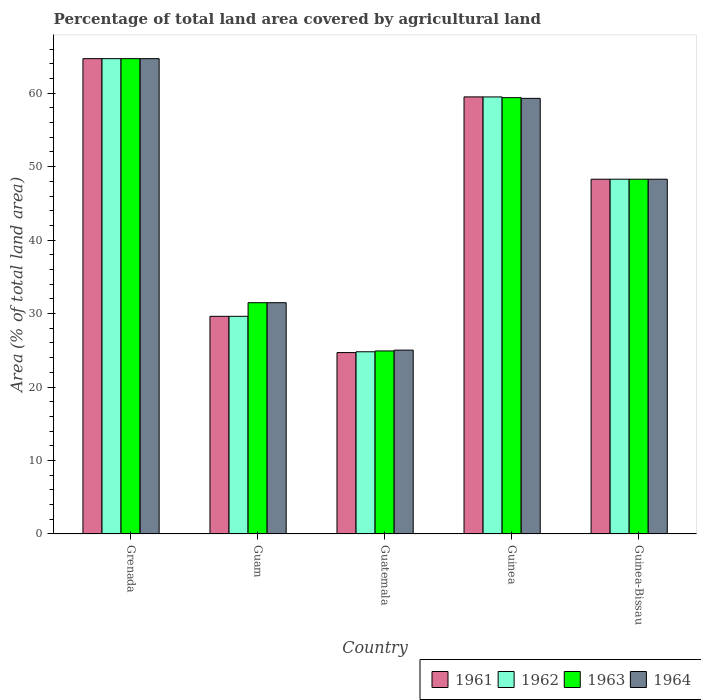How many groups of bars are there?
Your response must be concise. 5. Are the number of bars per tick equal to the number of legend labels?
Offer a terse response. Yes. How many bars are there on the 1st tick from the left?
Make the answer very short. 4. How many bars are there on the 1st tick from the right?
Make the answer very short. 4. What is the label of the 2nd group of bars from the left?
Offer a terse response. Guam. What is the percentage of agricultural land in 1961 in Guatemala?
Offer a terse response. 24.69. Across all countries, what is the maximum percentage of agricultural land in 1961?
Keep it short and to the point. 64.71. Across all countries, what is the minimum percentage of agricultural land in 1964?
Keep it short and to the point. 25.03. In which country was the percentage of agricultural land in 1963 maximum?
Give a very brief answer. Grenada. In which country was the percentage of agricultural land in 1963 minimum?
Give a very brief answer. Guatemala. What is the total percentage of agricultural land in 1963 in the graph?
Make the answer very short. 228.79. What is the difference between the percentage of agricultural land in 1964 in Guam and that in Guatemala?
Your answer should be compact. 6.45. What is the difference between the percentage of agricultural land in 1962 in Guam and the percentage of agricultural land in 1964 in Guatemala?
Ensure brevity in your answer.  4.6. What is the average percentage of agricultural land in 1963 per country?
Your answer should be very brief. 45.76. What is the difference between the percentage of agricultural land of/in 1962 and percentage of agricultural land of/in 1963 in Guatemala?
Offer a terse response. -0.11. What is the ratio of the percentage of agricultural land in 1961 in Guam to that in Guinea?
Offer a very short reply. 0.5. What is the difference between the highest and the second highest percentage of agricultural land in 1962?
Your response must be concise. 16.41. What is the difference between the highest and the lowest percentage of agricultural land in 1963?
Ensure brevity in your answer.  39.79. Is it the case that in every country, the sum of the percentage of agricultural land in 1961 and percentage of agricultural land in 1962 is greater than the sum of percentage of agricultural land in 1963 and percentage of agricultural land in 1964?
Your answer should be very brief. No. What does the 2nd bar from the left in Guam represents?
Make the answer very short. 1962. What does the 3rd bar from the right in Guinea represents?
Keep it short and to the point. 1962. Is it the case that in every country, the sum of the percentage of agricultural land in 1961 and percentage of agricultural land in 1962 is greater than the percentage of agricultural land in 1964?
Your answer should be very brief. Yes. Are all the bars in the graph horizontal?
Provide a short and direct response. No. Are the values on the major ticks of Y-axis written in scientific E-notation?
Make the answer very short. No. Does the graph contain any zero values?
Offer a terse response. No. Does the graph contain grids?
Give a very brief answer. No. How many legend labels are there?
Your answer should be compact. 4. What is the title of the graph?
Offer a very short reply. Percentage of total land area covered by agricultural land. Does "2002" appear as one of the legend labels in the graph?
Offer a very short reply. No. What is the label or title of the X-axis?
Offer a very short reply. Country. What is the label or title of the Y-axis?
Offer a terse response. Area (% of total land area). What is the Area (% of total land area) in 1961 in Grenada?
Provide a short and direct response. 64.71. What is the Area (% of total land area) in 1962 in Grenada?
Provide a succinct answer. 64.71. What is the Area (% of total land area) of 1963 in Grenada?
Your answer should be very brief. 64.71. What is the Area (% of total land area) of 1964 in Grenada?
Your response must be concise. 64.71. What is the Area (% of total land area) of 1961 in Guam?
Provide a short and direct response. 29.63. What is the Area (% of total land area) of 1962 in Guam?
Give a very brief answer. 29.63. What is the Area (% of total land area) of 1963 in Guam?
Keep it short and to the point. 31.48. What is the Area (% of total land area) of 1964 in Guam?
Offer a very short reply. 31.48. What is the Area (% of total land area) of 1961 in Guatemala?
Ensure brevity in your answer.  24.69. What is the Area (% of total land area) in 1962 in Guatemala?
Make the answer very short. 24.8. What is the Area (% of total land area) in 1963 in Guatemala?
Keep it short and to the point. 24.92. What is the Area (% of total land area) in 1964 in Guatemala?
Your answer should be compact. 25.03. What is the Area (% of total land area) in 1961 in Guinea?
Offer a very short reply. 59.5. What is the Area (% of total land area) in 1962 in Guinea?
Offer a very short reply. 59.49. What is the Area (% of total land area) of 1963 in Guinea?
Ensure brevity in your answer.  59.4. What is the Area (% of total land area) of 1964 in Guinea?
Your answer should be very brief. 59.3. What is the Area (% of total land area) of 1961 in Guinea-Bissau?
Give a very brief answer. 48.29. What is the Area (% of total land area) in 1962 in Guinea-Bissau?
Make the answer very short. 48.29. What is the Area (% of total land area) of 1963 in Guinea-Bissau?
Provide a succinct answer. 48.29. What is the Area (% of total land area) in 1964 in Guinea-Bissau?
Keep it short and to the point. 48.29. Across all countries, what is the maximum Area (% of total land area) in 1961?
Your response must be concise. 64.71. Across all countries, what is the maximum Area (% of total land area) in 1962?
Provide a succinct answer. 64.71. Across all countries, what is the maximum Area (% of total land area) of 1963?
Keep it short and to the point. 64.71. Across all countries, what is the maximum Area (% of total land area) in 1964?
Provide a succinct answer. 64.71. Across all countries, what is the minimum Area (% of total land area) in 1961?
Keep it short and to the point. 24.69. Across all countries, what is the minimum Area (% of total land area) in 1962?
Keep it short and to the point. 24.8. Across all countries, what is the minimum Area (% of total land area) of 1963?
Your response must be concise. 24.92. Across all countries, what is the minimum Area (% of total land area) of 1964?
Offer a very short reply. 25.03. What is the total Area (% of total land area) of 1961 in the graph?
Your answer should be compact. 226.82. What is the total Area (% of total land area) of 1962 in the graph?
Make the answer very short. 226.93. What is the total Area (% of total land area) of 1963 in the graph?
Give a very brief answer. 228.79. What is the total Area (% of total land area) in 1964 in the graph?
Keep it short and to the point. 228.81. What is the difference between the Area (% of total land area) in 1961 in Grenada and that in Guam?
Offer a very short reply. 35.08. What is the difference between the Area (% of total land area) of 1962 in Grenada and that in Guam?
Your answer should be very brief. 35.08. What is the difference between the Area (% of total land area) in 1963 in Grenada and that in Guam?
Offer a terse response. 33.22. What is the difference between the Area (% of total land area) in 1964 in Grenada and that in Guam?
Keep it short and to the point. 33.22. What is the difference between the Area (% of total land area) in 1961 in Grenada and that in Guatemala?
Offer a very short reply. 40.01. What is the difference between the Area (% of total land area) in 1962 in Grenada and that in Guatemala?
Make the answer very short. 39.9. What is the difference between the Area (% of total land area) of 1963 in Grenada and that in Guatemala?
Give a very brief answer. 39.79. What is the difference between the Area (% of total land area) of 1964 in Grenada and that in Guatemala?
Your answer should be compact. 39.68. What is the difference between the Area (% of total land area) of 1961 in Grenada and that in Guinea?
Keep it short and to the point. 5.21. What is the difference between the Area (% of total land area) of 1962 in Grenada and that in Guinea?
Ensure brevity in your answer.  5.21. What is the difference between the Area (% of total land area) in 1963 in Grenada and that in Guinea?
Make the answer very short. 5.31. What is the difference between the Area (% of total land area) in 1964 in Grenada and that in Guinea?
Offer a very short reply. 5.41. What is the difference between the Area (% of total land area) of 1961 in Grenada and that in Guinea-Bissau?
Your response must be concise. 16.41. What is the difference between the Area (% of total land area) in 1962 in Grenada and that in Guinea-Bissau?
Make the answer very short. 16.41. What is the difference between the Area (% of total land area) in 1963 in Grenada and that in Guinea-Bissau?
Offer a terse response. 16.41. What is the difference between the Area (% of total land area) of 1964 in Grenada and that in Guinea-Bissau?
Offer a very short reply. 16.41. What is the difference between the Area (% of total land area) in 1961 in Guam and that in Guatemala?
Keep it short and to the point. 4.94. What is the difference between the Area (% of total land area) in 1962 in Guam and that in Guatemala?
Offer a terse response. 4.83. What is the difference between the Area (% of total land area) of 1963 in Guam and that in Guatemala?
Keep it short and to the point. 6.57. What is the difference between the Area (% of total land area) in 1964 in Guam and that in Guatemala?
Your answer should be compact. 6.45. What is the difference between the Area (% of total land area) in 1961 in Guam and that in Guinea?
Provide a short and direct response. -29.87. What is the difference between the Area (% of total land area) in 1962 in Guam and that in Guinea?
Provide a short and direct response. -29.86. What is the difference between the Area (% of total land area) in 1963 in Guam and that in Guinea?
Keep it short and to the point. -27.92. What is the difference between the Area (% of total land area) of 1964 in Guam and that in Guinea?
Your answer should be compact. -27.82. What is the difference between the Area (% of total land area) in 1961 in Guam and that in Guinea-Bissau?
Provide a succinct answer. -18.66. What is the difference between the Area (% of total land area) in 1962 in Guam and that in Guinea-Bissau?
Provide a short and direct response. -18.66. What is the difference between the Area (% of total land area) of 1963 in Guam and that in Guinea-Bissau?
Ensure brevity in your answer.  -16.81. What is the difference between the Area (% of total land area) of 1964 in Guam and that in Guinea-Bissau?
Your answer should be compact. -16.81. What is the difference between the Area (% of total land area) of 1961 in Guatemala and that in Guinea?
Your answer should be compact. -34.81. What is the difference between the Area (% of total land area) in 1962 in Guatemala and that in Guinea?
Provide a succinct answer. -34.69. What is the difference between the Area (% of total land area) in 1963 in Guatemala and that in Guinea?
Make the answer very short. -34.48. What is the difference between the Area (% of total land area) of 1964 in Guatemala and that in Guinea?
Keep it short and to the point. -34.27. What is the difference between the Area (% of total land area) in 1961 in Guatemala and that in Guinea-Bissau?
Your response must be concise. -23.6. What is the difference between the Area (% of total land area) in 1962 in Guatemala and that in Guinea-Bissau?
Your response must be concise. -23.49. What is the difference between the Area (% of total land area) in 1963 in Guatemala and that in Guinea-Bissau?
Make the answer very short. -23.38. What is the difference between the Area (% of total land area) of 1964 in Guatemala and that in Guinea-Bissau?
Your response must be concise. -23.27. What is the difference between the Area (% of total land area) in 1961 in Guinea and that in Guinea-Bissau?
Provide a succinct answer. 11.21. What is the difference between the Area (% of total land area) in 1962 in Guinea and that in Guinea-Bissau?
Give a very brief answer. 11.2. What is the difference between the Area (% of total land area) in 1963 in Guinea and that in Guinea-Bissau?
Make the answer very short. 11.1. What is the difference between the Area (% of total land area) in 1964 in Guinea and that in Guinea-Bissau?
Your response must be concise. 11.01. What is the difference between the Area (% of total land area) of 1961 in Grenada and the Area (% of total land area) of 1962 in Guam?
Provide a succinct answer. 35.08. What is the difference between the Area (% of total land area) in 1961 in Grenada and the Area (% of total land area) in 1963 in Guam?
Give a very brief answer. 33.22. What is the difference between the Area (% of total land area) of 1961 in Grenada and the Area (% of total land area) of 1964 in Guam?
Your response must be concise. 33.22. What is the difference between the Area (% of total land area) in 1962 in Grenada and the Area (% of total land area) in 1963 in Guam?
Your answer should be compact. 33.22. What is the difference between the Area (% of total land area) of 1962 in Grenada and the Area (% of total land area) of 1964 in Guam?
Give a very brief answer. 33.22. What is the difference between the Area (% of total land area) of 1963 in Grenada and the Area (% of total land area) of 1964 in Guam?
Your response must be concise. 33.22. What is the difference between the Area (% of total land area) of 1961 in Grenada and the Area (% of total land area) of 1962 in Guatemala?
Your answer should be very brief. 39.9. What is the difference between the Area (% of total land area) in 1961 in Grenada and the Area (% of total land area) in 1963 in Guatemala?
Give a very brief answer. 39.79. What is the difference between the Area (% of total land area) in 1961 in Grenada and the Area (% of total land area) in 1964 in Guatemala?
Provide a short and direct response. 39.68. What is the difference between the Area (% of total land area) in 1962 in Grenada and the Area (% of total land area) in 1963 in Guatemala?
Your response must be concise. 39.79. What is the difference between the Area (% of total land area) of 1962 in Grenada and the Area (% of total land area) of 1964 in Guatemala?
Provide a succinct answer. 39.68. What is the difference between the Area (% of total land area) of 1963 in Grenada and the Area (% of total land area) of 1964 in Guatemala?
Provide a short and direct response. 39.68. What is the difference between the Area (% of total land area) of 1961 in Grenada and the Area (% of total land area) of 1962 in Guinea?
Your answer should be very brief. 5.21. What is the difference between the Area (% of total land area) of 1961 in Grenada and the Area (% of total land area) of 1963 in Guinea?
Your answer should be compact. 5.31. What is the difference between the Area (% of total land area) in 1961 in Grenada and the Area (% of total land area) in 1964 in Guinea?
Ensure brevity in your answer.  5.41. What is the difference between the Area (% of total land area) of 1962 in Grenada and the Area (% of total land area) of 1963 in Guinea?
Make the answer very short. 5.31. What is the difference between the Area (% of total land area) of 1962 in Grenada and the Area (% of total land area) of 1964 in Guinea?
Ensure brevity in your answer.  5.41. What is the difference between the Area (% of total land area) of 1963 in Grenada and the Area (% of total land area) of 1964 in Guinea?
Provide a succinct answer. 5.41. What is the difference between the Area (% of total land area) in 1961 in Grenada and the Area (% of total land area) in 1962 in Guinea-Bissau?
Make the answer very short. 16.41. What is the difference between the Area (% of total land area) in 1961 in Grenada and the Area (% of total land area) in 1963 in Guinea-Bissau?
Offer a very short reply. 16.41. What is the difference between the Area (% of total land area) of 1961 in Grenada and the Area (% of total land area) of 1964 in Guinea-Bissau?
Your answer should be compact. 16.41. What is the difference between the Area (% of total land area) in 1962 in Grenada and the Area (% of total land area) in 1963 in Guinea-Bissau?
Your response must be concise. 16.41. What is the difference between the Area (% of total land area) of 1962 in Grenada and the Area (% of total land area) of 1964 in Guinea-Bissau?
Your response must be concise. 16.41. What is the difference between the Area (% of total land area) of 1963 in Grenada and the Area (% of total land area) of 1964 in Guinea-Bissau?
Make the answer very short. 16.41. What is the difference between the Area (% of total land area) in 1961 in Guam and the Area (% of total land area) in 1962 in Guatemala?
Offer a terse response. 4.83. What is the difference between the Area (% of total land area) of 1961 in Guam and the Area (% of total land area) of 1963 in Guatemala?
Provide a succinct answer. 4.71. What is the difference between the Area (% of total land area) in 1961 in Guam and the Area (% of total land area) in 1964 in Guatemala?
Your answer should be very brief. 4.6. What is the difference between the Area (% of total land area) in 1962 in Guam and the Area (% of total land area) in 1963 in Guatemala?
Offer a terse response. 4.71. What is the difference between the Area (% of total land area) in 1962 in Guam and the Area (% of total land area) in 1964 in Guatemala?
Make the answer very short. 4.6. What is the difference between the Area (% of total land area) in 1963 in Guam and the Area (% of total land area) in 1964 in Guatemala?
Offer a terse response. 6.45. What is the difference between the Area (% of total land area) of 1961 in Guam and the Area (% of total land area) of 1962 in Guinea?
Offer a very short reply. -29.86. What is the difference between the Area (% of total land area) of 1961 in Guam and the Area (% of total land area) of 1963 in Guinea?
Offer a very short reply. -29.77. What is the difference between the Area (% of total land area) in 1961 in Guam and the Area (% of total land area) in 1964 in Guinea?
Offer a terse response. -29.67. What is the difference between the Area (% of total land area) in 1962 in Guam and the Area (% of total land area) in 1963 in Guinea?
Offer a very short reply. -29.77. What is the difference between the Area (% of total land area) of 1962 in Guam and the Area (% of total land area) of 1964 in Guinea?
Provide a short and direct response. -29.67. What is the difference between the Area (% of total land area) of 1963 in Guam and the Area (% of total land area) of 1964 in Guinea?
Your response must be concise. -27.82. What is the difference between the Area (% of total land area) of 1961 in Guam and the Area (% of total land area) of 1962 in Guinea-Bissau?
Keep it short and to the point. -18.66. What is the difference between the Area (% of total land area) of 1961 in Guam and the Area (% of total land area) of 1963 in Guinea-Bissau?
Ensure brevity in your answer.  -18.66. What is the difference between the Area (% of total land area) in 1961 in Guam and the Area (% of total land area) in 1964 in Guinea-Bissau?
Ensure brevity in your answer.  -18.66. What is the difference between the Area (% of total land area) in 1962 in Guam and the Area (% of total land area) in 1963 in Guinea-Bissau?
Keep it short and to the point. -18.66. What is the difference between the Area (% of total land area) in 1962 in Guam and the Area (% of total land area) in 1964 in Guinea-Bissau?
Give a very brief answer. -18.66. What is the difference between the Area (% of total land area) in 1963 in Guam and the Area (% of total land area) in 1964 in Guinea-Bissau?
Offer a terse response. -16.81. What is the difference between the Area (% of total land area) of 1961 in Guatemala and the Area (% of total land area) of 1962 in Guinea?
Offer a terse response. -34.8. What is the difference between the Area (% of total land area) in 1961 in Guatemala and the Area (% of total land area) in 1963 in Guinea?
Ensure brevity in your answer.  -34.7. What is the difference between the Area (% of total land area) in 1961 in Guatemala and the Area (% of total land area) in 1964 in Guinea?
Offer a very short reply. -34.61. What is the difference between the Area (% of total land area) of 1962 in Guatemala and the Area (% of total land area) of 1963 in Guinea?
Your answer should be compact. -34.59. What is the difference between the Area (% of total land area) of 1962 in Guatemala and the Area (% of total land area) of 1964 in Guinea?
Your answer should be compact. -34.5. What is the difference between the Area (% of total land area) of 1963 in Guatemala and the Area (% of total land area) of 1964 in Guinea?
Make the answer very short. -34.38. What is the difference between the Area (% of total land area) of 1961 in Guatemala and the Area (% of total land area) of 1962 in Guinea-Bissau?
Offer a terse response. -23.6. What is the difference between the Area (% of total land area) in 1961 in Guatemala and the Area (% of total land area) in 1963 in Guinea-Bissau?
Your response must be concise. -23.6. What is the difference between the Area (% of total land area) of 1961 in Guatemala and the Area (% of total land area) of 1964 in Guinea-Bissau?
Offer a very short reply. -23.6. What is the difference between the Area (% of total land area) of 1962 in Guatemala and the Area (% of total land area) of 1963 in Guinea-Bissau?
Provide a succinct answer. -23.49. What is the difference between the Area (% of total land area) in 1962 in Guatemala and the Area (% of total land area) in 1964 in Guinea-Bissau?
Your answer should be very brief. -23.49. What is the difference between the Area (% of total land area) of 1963 in Guatemala and the Area (% of total land area) of 1964 in Guinea-Bissau?
Your answer should be compact. -23.38. What is the difference between the Area (% of total land area) in 1961 in Guinea and the Area (% of total land area) in 1962 in Guinea-Bissau?
Provide a succinct answer. 11.21. What is the difference between the Area (% of total land area) in 1961 in Guinea and the Area (% of total land area) in 1963 in Guinea-Bissau?
Ensure brevity in your answer.  11.21. What is the difference between the Area (% of total land area) in 1961 in Guinea and the Area (% of total land area) in 1964 in Guinea-Bissau?
Your answer should be compact. 11.21. What is the difference between the Area (% of total land area) of 1962 in Guinea and the Area (% of total land area) of 1963 in Guinea-Bissau?
Ensure brevity in your answer.  11.2. What is the difference between the Area (% of total land area) of 1962 in Guinea and the Area (% of total land area) of 1964 in Guinea-Bissau?
Your response must be concise. 11.2. What is the difference between the Area (% of total land area) of 1963 in Guinea and the Area (% of total land area) of 1964 in Guinea-Bissau?
Give a very brief answer. 11.1. What is the average Area (% of total land area) of 1961 per country?
Keep it short and to the point. 45.36. What is the average Area (% of total land area) in 1962 per country?
Offer a terse response. 45.39. What is the average Area (% of total land area) in 1963 per country?
Make the answer very short. 45.76. What is the average Area (% of total land area) of 1964 per country?
Offer a very short reply. 45.76. What is the difference between the Area (% of total land area) in 1962 and Area (% of total land area) in 1963 in Grenada?
Offer a terse response. 0. What is the difference between the Area (% of total land area) of 1962 and Area (% of total land area) of 1964 in Grenada?
Your answer should be compact. 0. What is the difference between the Area (% of total land area) of 1963 and Area (% of total land area) of 1964 in Grenada?
Keep it short and to the point. 0. What is the difference between the Area (% of total land area) in 1961 and Area (% of total land area) in 1963 in Guam?
Offer a terse response. -1.85. What is the difference between the Area (% of total land area) of 1961 and Area (% of total land area) of 1964 in Guam?
Keep it short and to the point. -1.85. What is the difference between the Area (% of total land area) of 1962 and Area (% of total land area) of 1963 in Guam?
Keep it short and to the point. -1.85. What is the difference between the Area (% of total land area) of 1962 and Area (% of total land area) of 1964 in Guam?
Provide a short and direct response. -1.85. What is the difference between the Area (% of total land area) of 1963 and Area (% of total land area) of 1964 in Guam?
Your answer should be compact. 0. What is the difference between the Area (% of total land area) of 1961 and Area (% of total land area) of 1962 in Guatemala?
Provide a succinct answer. -0.11. What is the difference between the Area (% of total land area) in 1961 and Area (% of total land area) in 1963 in Guatemala?
Your answer should be very brief. -0.22. What is the difference between the Area (% of total land area) of 1961 and Area (% of total land area) of 1964 in Guatemala?
Your answer should be very brief. -0.34. What is the difference between the Area (% of total land area) in 1962 and Area (% of total land area) in 1963 in Guatemala?
Offer a very short reply. -0.11. What is the difference between the Area (% of total land area) in 1962 and Area (% of total land area) in 1964 in Guatemala?
Provide a succinct answer. -0.22. What is the difference between the Area (% of total land area) in 1963 and Area (% of total land area) in 1964 in Guatemala?
Make the answer very short. -0.11. What is the difference between the Area (% of total land area) in 1961 and Area (% of total land area) in 1962 in Guinea?
Make the answer very short. 0. What is the difference between the Area (% of total land area) in 1961 and Area (% of total land area) in 1963 in Guinea?
Your answer should be compact. 0.1. What is the difference between the Area (% of total land area) of 1961 and Area (% of total land area) of 1964 in Guinea?
Keep it short and to the point. 0.2. What is the difference between the Area (% of total land area) in 1962 and Area (% of total land area) in 1963 in Guinea?
Your answer should be compact. 0.1. What is the difference between the Area (% of total land area) of 1962 and Area (% of total land area) of 1964 in Guinea?
Make the answer very short. 0.2. What is the difference between the Area (% of total land area) in 1963 and Area (% of total land area) in 1964 in Guinea?
Provide a succinct answer. 0.1. What is the difference between the Area (% of total land area) of 1961 and Area (% of total land area) of 1963 in Guinea-Bissau?
Provide a short and direct response. 0. What is the ratio of the Area (% of total land area) of 1961 in Grenada to that in Guam?
Your response must be concise. 2.18. What is the ratio of the Area (% of total land area) of 1962 in Grenada to that in Guam?
Provide a short and direct response. 2.18. What is the ratio of the Area (% of total land area) in 1963 in Grenada to that in Guam?
Provide a short and direct response. 2.06. What is the ratio of the Area (% of total land area) of 1964 in Grenada to that in Guam?
Offer a terse response. 2.06. What is the ratio of the Area (% of total land area) of 1961 in Grenada to that in Guatemala?
Provide a short and direct response. 2.62. What is the ratio of the Area (% of total land area) in 1962 in Grenada to that in Guatemala?
Make the answer very short. 2.61. What is the ratio of the Area (% of total land area) of 1963 in Grenada to that in Guatemala?
Provide a succinct answer. 2.6. What is the ratio of the Area (% of total land area) in 1964 in Grenada to that in Guatemala?
Your response must be concise. 2.59. What is the ratio of the Area (% of total land area) in 1961 in Grenada to that in Guinea?
Ensure brevity in your answer.  1.09. What is the ratio of the Area (% of total land area) of 1962 in Grenada to that in Guinea?
Make the answer very short. 1.09. What is the ratio of the Area (% of total land area) in 1963 in Grenada to that in Guinea?
Keep it short and to the point. 1.09. What is the ratio of the Area (% of total land area) of 1964 in Grenada to that in Guinea?
Give a very brief answer. 1.09. What is the ratio of the Area (% of total land area) in 1961 in Grenada to that in Guinea-Bissau?
Provide a short and direct response. 1.34. What is the ratio of the Area (% of total land area) in 1962 in Grenada to that in Guinea-Bissau?
Provide a succinct answer. 1.34. What is the ratio of the Area (% of total land area) of 1963 in Grenada to that in Guinea-Bissau?
Your answer should be compact. 1.34. What is the ratio of the Area (% of total land area) in 1964 in Grenada to that in Guinea-Bissau?
Give a very brief answer. 1.34. What is the ratio of the Area (% of total land area) in 1962 in Guam to that in Guatemala?
Offer a very short reply. 1.19. What is the ratio of the Area (% of total land area) of 1963 in Guam to that in Guatemala?
Your answer should be very brief. 1.26. What is the ratio of the Area (% of total land area) of 1964 in Guam to that in Guatemala?
Keep it short and to the point. 1.26. What is the ratio of the Area (% of total land area) of 1961 in Guam to that in Guinea?
Offer a very short reply. 0.5. What is the ratio of the Area (% of total land area) of 1962 in Guam to that in Guinea?
Your answer should be very brief. 0.5. What is the ratio of the Area (% of total land area) in 1963 in Guam to that in Guinea?
Make the answer very short. 0.53. What is the ratio of the Area (% of total land area) of 1964 in Guam to that in Guinea?
Offer a very short reply. 0.53. What is the ratio of the Area (% of total land area) in 1961 in Guam to that in Guinea-Bissau?
Give a very brief answer. 0.61. What is the ratio of the Area (% of total land area) in 1962 in Guam to that in Guinea-Bissau?
Your answer should be compact. 0.61. What is the ratio of the Area (% of total land area) of 1963 in Guam to that in Guinea-Bissau?
Your response must be concise. 0.65. What is the ratio of the Area (% of total land area) in 1964 in Guam to that in Guinea-Bissau?
Your answer should be compact. 0.65. What is the ratio of the Area (% of total land area) in 1961 in Guatemala to that in Guinea?
Keep it short and to the point. 0.41. What is the ratio of the Area (% of total land area) of 1962 in Guatemala to that in Guinea?
Give a very brief answer. 0.42. What is the ratio of the Area (% of total land area) in 1963 in Guatemala to that in Guinea?
Provide a short and direct response. 0.42. What is the ratio of the Area (% of total land area) of 1964 in Guatemala to that in Guinea?
Offer a terse response. 0.42. What is the ratio of the Area (% of total land area) in 1961 in Guatemala to that in Guinea-Bissau?
Give a very brief answer. 0.51. What is the ratio of the Area (% of total land area) in 1962 in Guatemala to that in Guinea-Bissau?
Offer a terse response. 0.51. What is the ratio of the Area (% of total land area) of 1963 in Guatemala to that in Guinea-Bissau?
Provide a short and direct response. 0.52. What is the ratio of the Area (% of total land area) in 1964 in Guatemala to that in Guinea-Bissau?
Your response must be concise. 0.52. What is the ratio of the Area (% of total land area) in 1961 in Guinea to that in Guinea-Bissau?
Provide a succinct answer. 1.23. What is the ratio of the Area (% of total land area) of 1962 in Guinea to that in Guinea-Bissau?
Your answer should be compact. 1.23. What is the ratio of the Area (% of total land area) in 1963 in Guinea to that in Guinea-Bissau?
Ensure brevity in your answer.  1.23. What is the ratio of the Area (% of total land area) in 1964 in Guinea to that in Guinea-Bissau?
Keep it short and to the point. 1.23. What is the difference between the highest and the second highest Area (% of total land area) in 1961?
Provide a succinct answer. 5.21. What is the difference between the highest and the second highest Area (% of total land area) of 1962?
Your answer should be very brief. 5.21. What is the difference between the highest and the second highest Area (% of total land area) of 1963?
Provide a succinct answer. 5.31. What is the difference between the highest and the second highest Area (% of total land area) of 1964?
Your response must be concise. 5.41. What is the difference between the highest and the lowest Area (% of total land area) of 1961?
Give a very brief answer. 40.01. What is the difference between the highest and the lowest Area (% of total land area) in 1962?
Your answer should be compact. 39.9. What is the difference between the highest and the lowest Area (% of total land area) of 1963?
Your answer should be compact. 39.79. What is the difference between the highest and the lowest Area (% of total land area) in 1964?
Keep it short and to the point. 39.68. 